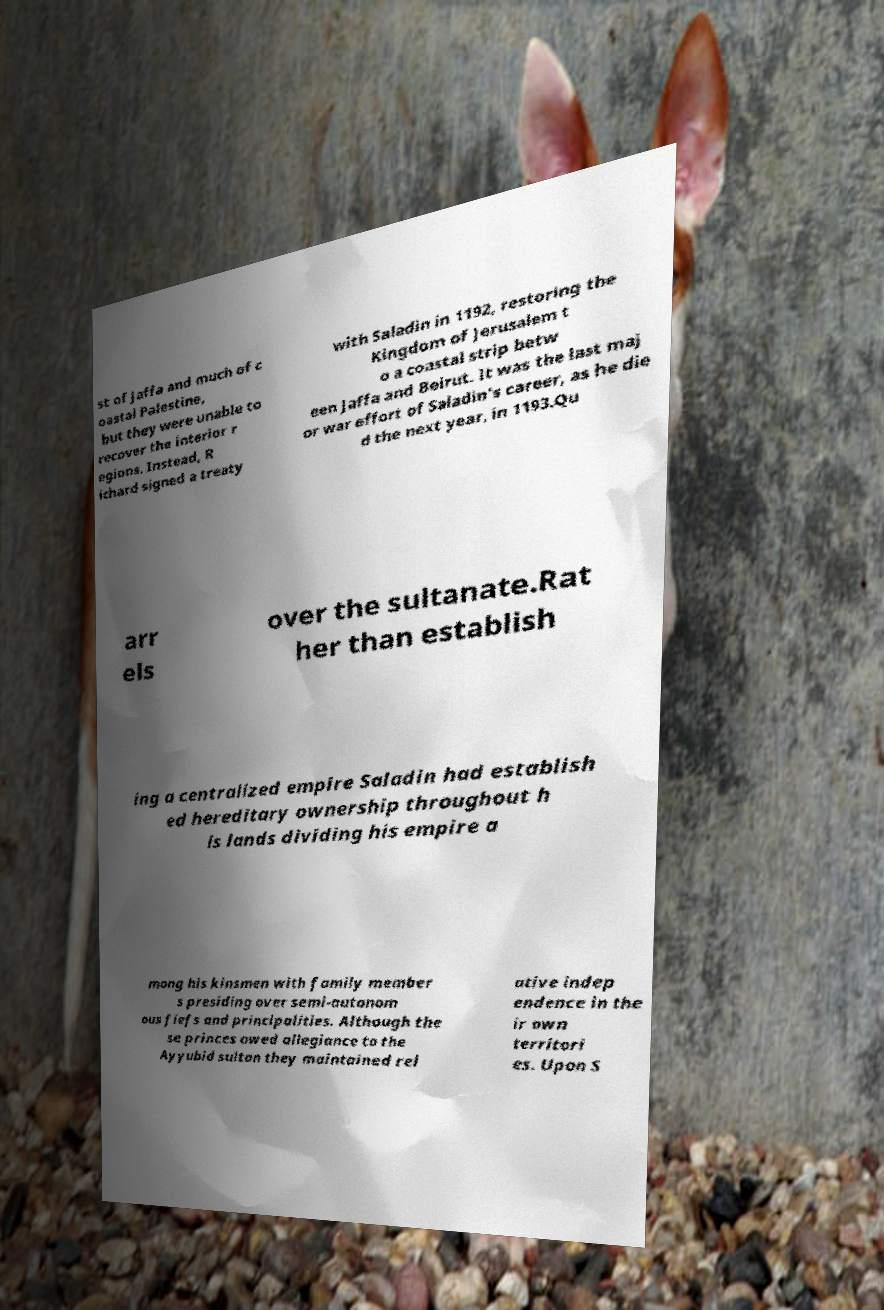I need the written content from this picture converted into text. Can you do that? st of Jaffa and much of c oastal Palestine, but they were unable to recover the interior r egions. Instead, R ichard signed a treaty with Saladin in 1192, restoring the Kingdom of Jerusalem t o a coastal strip betw een Jaffa and Beirut. It was the last maj or war effort of Saladin's career, as he die d the next year, in 1193.Qu arr els over the sultanate.Rat her than establish ing a centralized empire Saladin had establish ed hereditary ownership throughout h is lands dividing his empire a mong his kinsmen with family member s presiding over semi-autonom ous fiefs and principalities. Although the se princes owed allegiance to the Ayyubid sultan they maintained rel ative indep endence in the ir own territori es. Upon S 